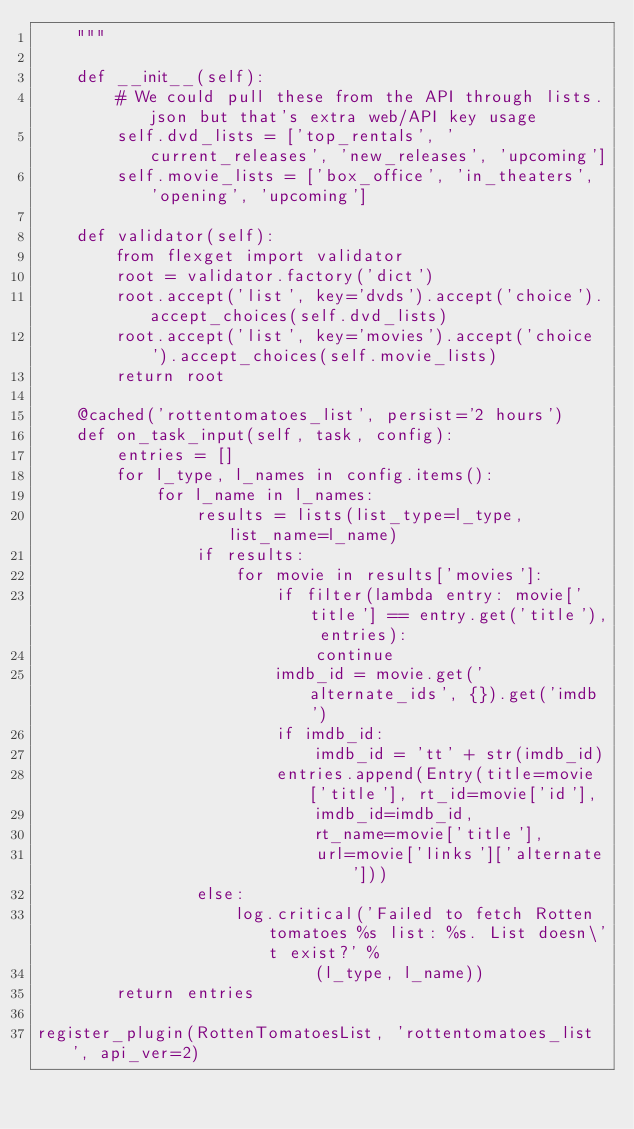<code> <loc_0><loc_0><loc_500><loc_500><_Python_>    """

    def __init__(self):
        # We could pull these from the API through lists.json but that's extra web/API key usage
        self.dvd_lists = ['top_rentals', 'current_releases', 'new_releases', 'upcoming']
        self.movie_lists = ['box_office', 'in_theaters', 'opening', 'upcoming']

    def validator(self):
        from flexget import validator
        root = validator.factory('dict')
        root.accept('list', key='dvds').accept('choice').accept_choices(self.dvd_lists)
        root.accept('list', key='movies').accept('choice').accept_choices(self.movie_lists)
        return root

    @cached('rottentomatoes_list', persist='2 hours')
    def on_task_input(self, task, config):
        entries = []
        for l_type, l_names in config.items():
            for l_name in l_names:
                results = lists(list_type=l_type, list_name=l_name)
                if results:
                    for movie in results['movies']:
                        if filter(lambda entry: movie['title'] == entry.get('title'), entries):
                            continue
                        imdb_id = movie.get('alternate_ids', {}).get('imdb')
                        if imdb_id:
                            imdb_id = 'tt' + str(imdb_id)
                        entries.append(Entry(title=movie['title'], rt_id=movie['id'],
                            imdb_id=imdb_id,
                            rt_name=movie['title'],
                            url=movie['links']['alternate']))
                else:
                    log.critical('Failed to fetch Rotten tomatoes %s list: %s. List doesn\'t exist?' %
                            (l_type, l_name))
        return entries

register_plugin(RottenTomatoesList, 'rottentomatoes_list', api_ver=2)
</code> 